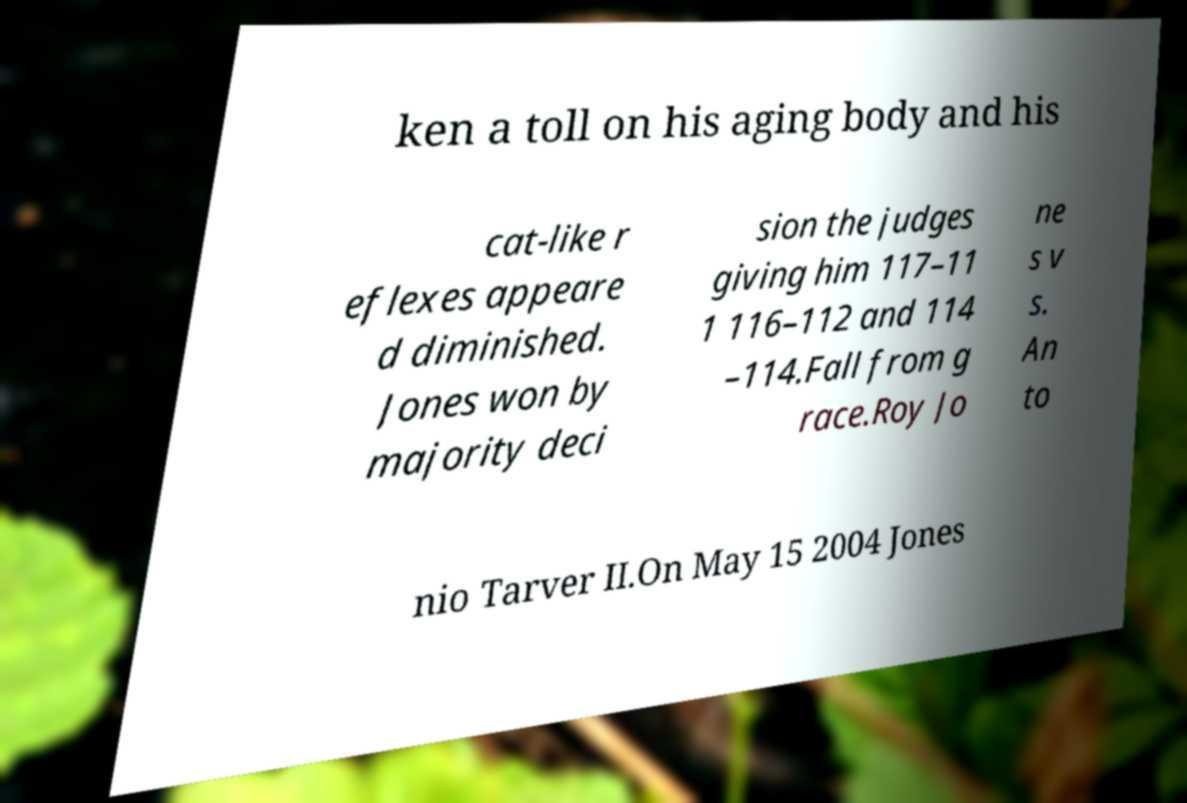Could you extract and type out the text from this image? ken a toll on his aging body and his cat-like r eflexes appeare d diminished. Jones won by majority deci sion the judges giving him 117–11 1 116–112 and 114 –114.Fall from g race.Roy Jo ne s v s. An to nio Tarver II.On May 15 2004 Jones 